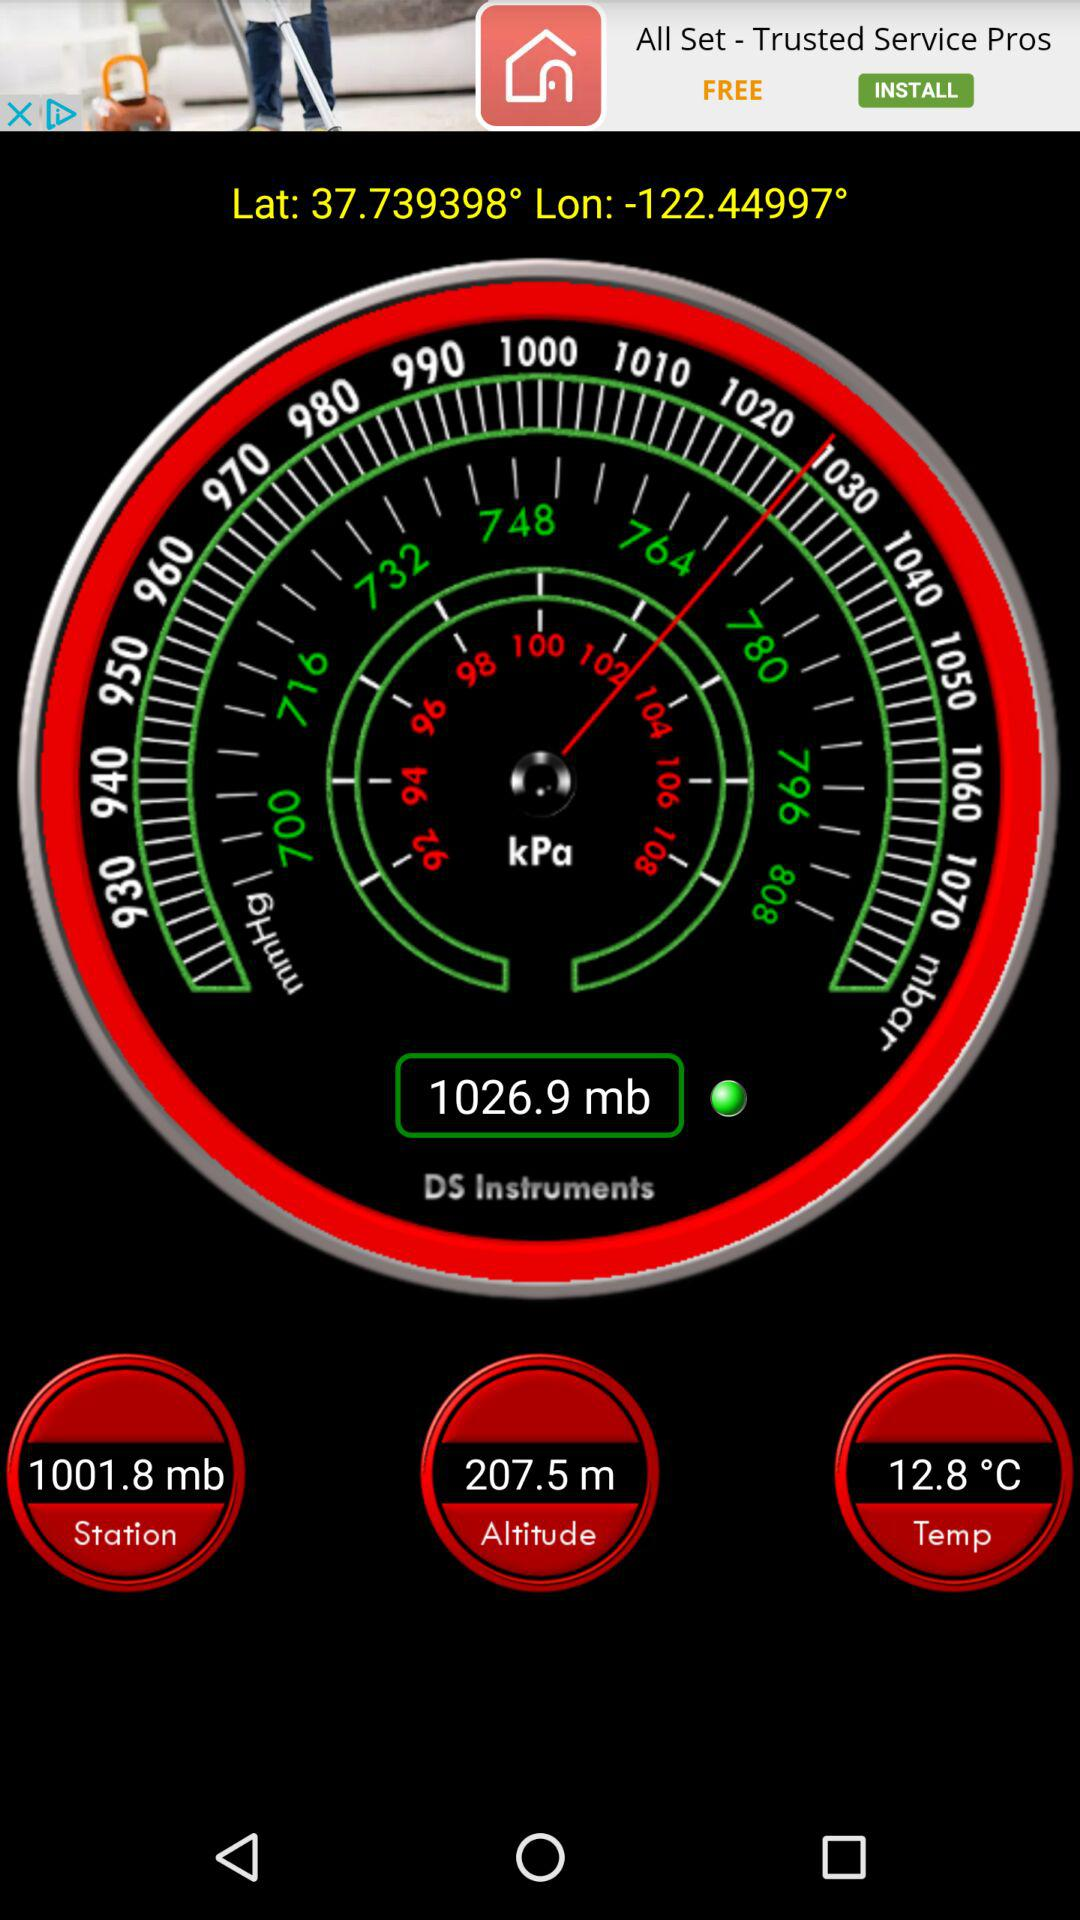What is the latitude and longitude mentioned? The latitude is 37.739398° and the longitude is -122.44997°. 